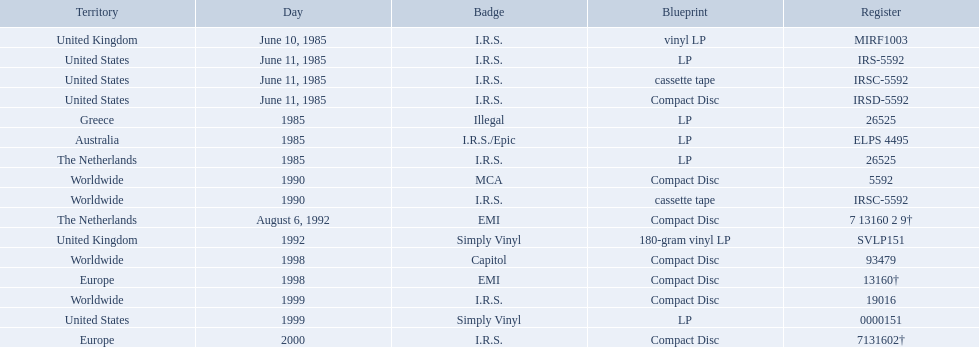In which regions was the fables of the reconstruction album released? United Kingdom, United States, United States, United States, Greece, Australia, The Netherlands, Worldwide, Worldwide, The Netherlands, United Kingdom, Worldwide, Europe, Worldwide, United States, Europe. And what were the release dates for those regions? June 10, 1985, June 11, 1985, June 11, 1985, June 11, 1985, 1985, 1985, 1985, 1990, 1990, August 6, 1992, 1992, 1998, 1998, 1999, 1999, 2000. And which region was listed after greece in 1985? Australia. What dates were lps of any kind released? June 10, 1985, June 11, 1985, 1985, 1985, 1985, 1992, 1999. In which countries were these released in by i.r.s.? United Kingdom, United States, Australia, The Netherlands. Which of these countries is not in the northern hemisphere? Australia. 